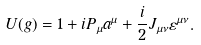<formula> <loc_0><loc_0><loc_500><loc_500>U ( g ) = 1 + i P _ { \mu } a ^ { \mu } + \frac { i } { 2 } J _ { \mu \nu } \varepsilon ^ { \mu \nu } .</formula> 